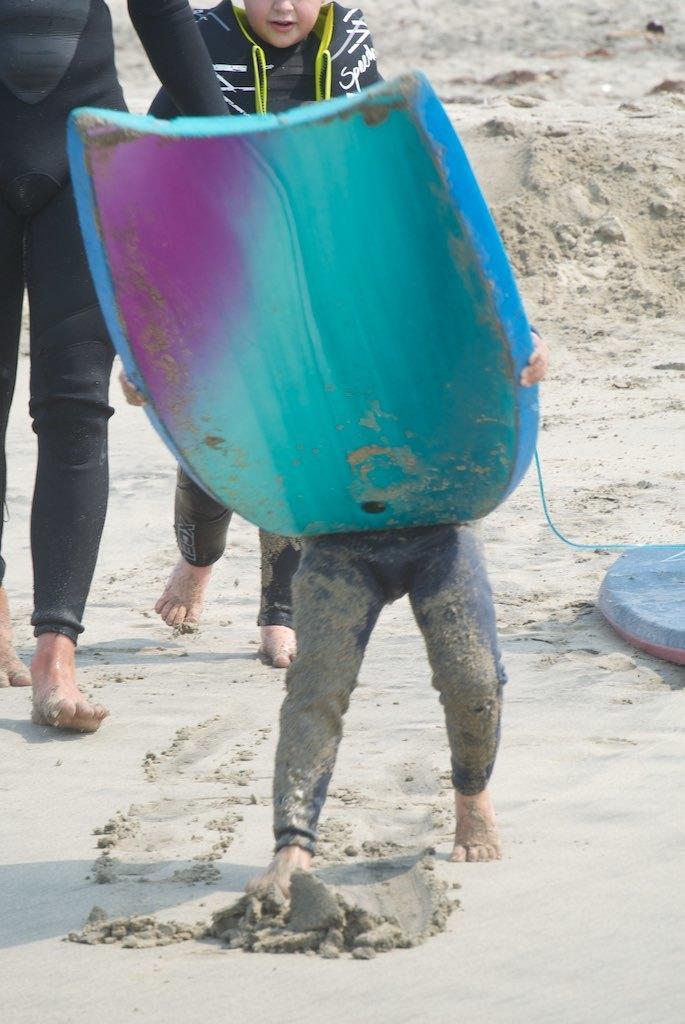Describe this image in one or two sentences. In the picture I can see people are walking on the ground. I can also see a person is holding an object in hands. 